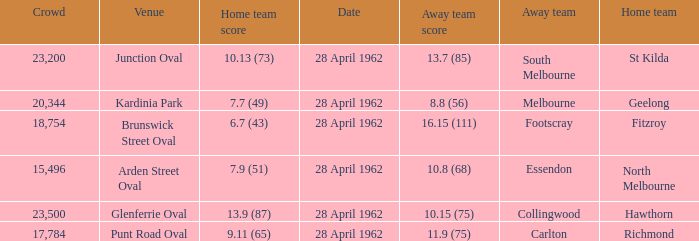What away team played at Brunswick Street Oval? Footscray. 